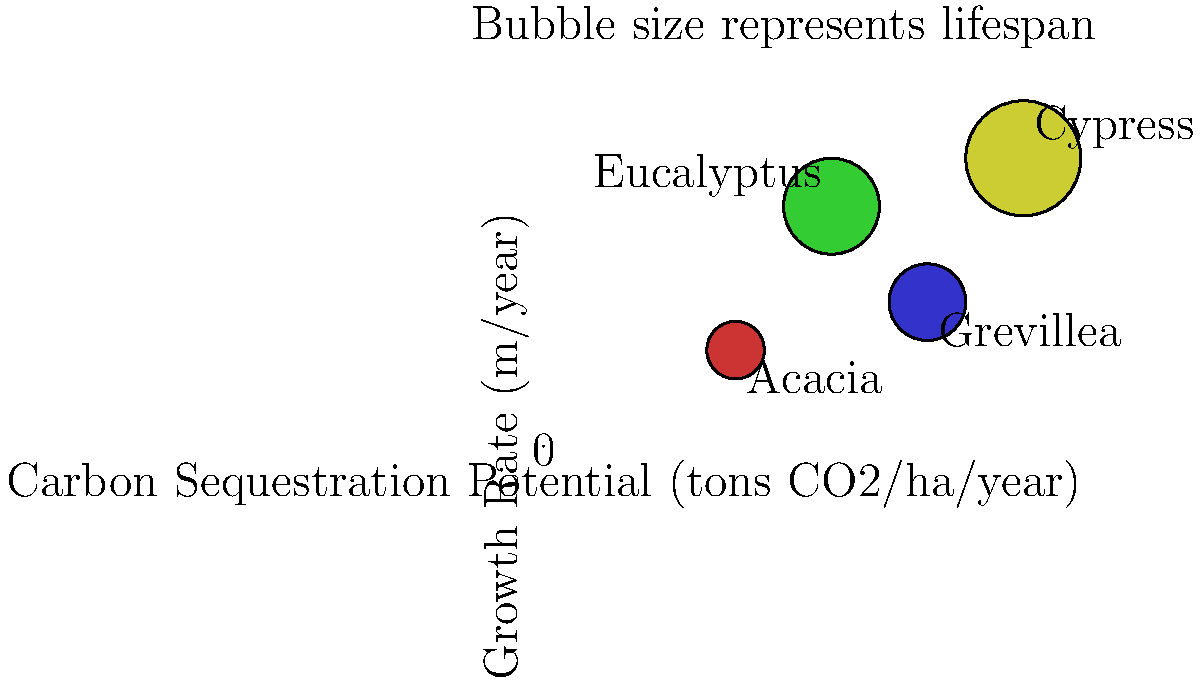Based on the bubble chart illustrating the carbon sequestration potential, growth rate, and lifespan of different tree species in Kenya, which species appears to have the highest overall potential for long-term carbon storage? To determine the tree species with the highest overall potential for long-term carbon storage, we need to consider three factors represented in the bubble chart:

1. Carbon Sequestration Potential (x-axis): This represents the amount of CO2 the tree can absorb per hectare per year. A higher value indicates greater carbon absorption.

2. Growth Rate (y-axis): This shows how quickly the tree grows. Faster-growing trees can start sequestering carbon more quickly.

3. Lifespan (bubble size): Larger bubbles indicate longer lifespans. Trees with longer lifespans can store carbon for extended periods.

Analyzing each species:

1. Acacia: Low carbon sequestration potential, slow growth rate, and short lifespan.
2. Eucalyptus: Moderate carbon sequestration potential, high growth rate, and moderate lifespan.
3. Grevillea: Moderately high carbon sequestration potential, moderate growth rate, and moderate lifespan.
4. Cypress: Highest carbon sequestration potential, highest growth rate, and longest lifespan.

The Cypress species excels in all three categories:
- It has the highest carbon sequestration potential (furthest right on the x-axis).
- It has the fastest growth rate (highest on the y-axis).
- It has the longest lifespan (largest bubble size).

These characteristics combined make Cypress the most effective for long-term carbon storage among the species shown.
Answer: Cypress 